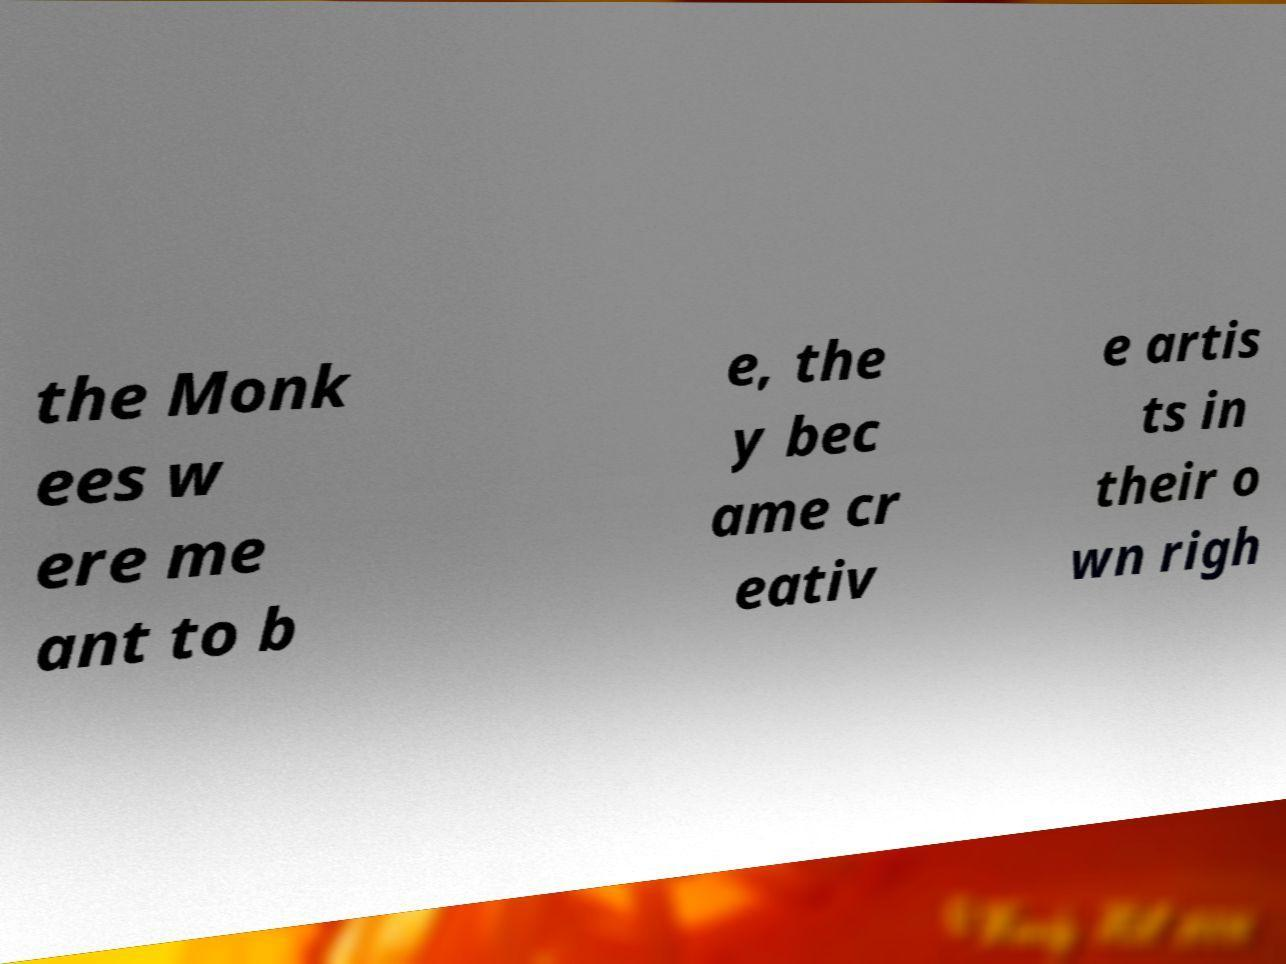Please read and relay the text visible in this image. What does it say? the Monk ees w ere me ant to b e, the y bec ame cr eativ e artis ts in their o wn righ 